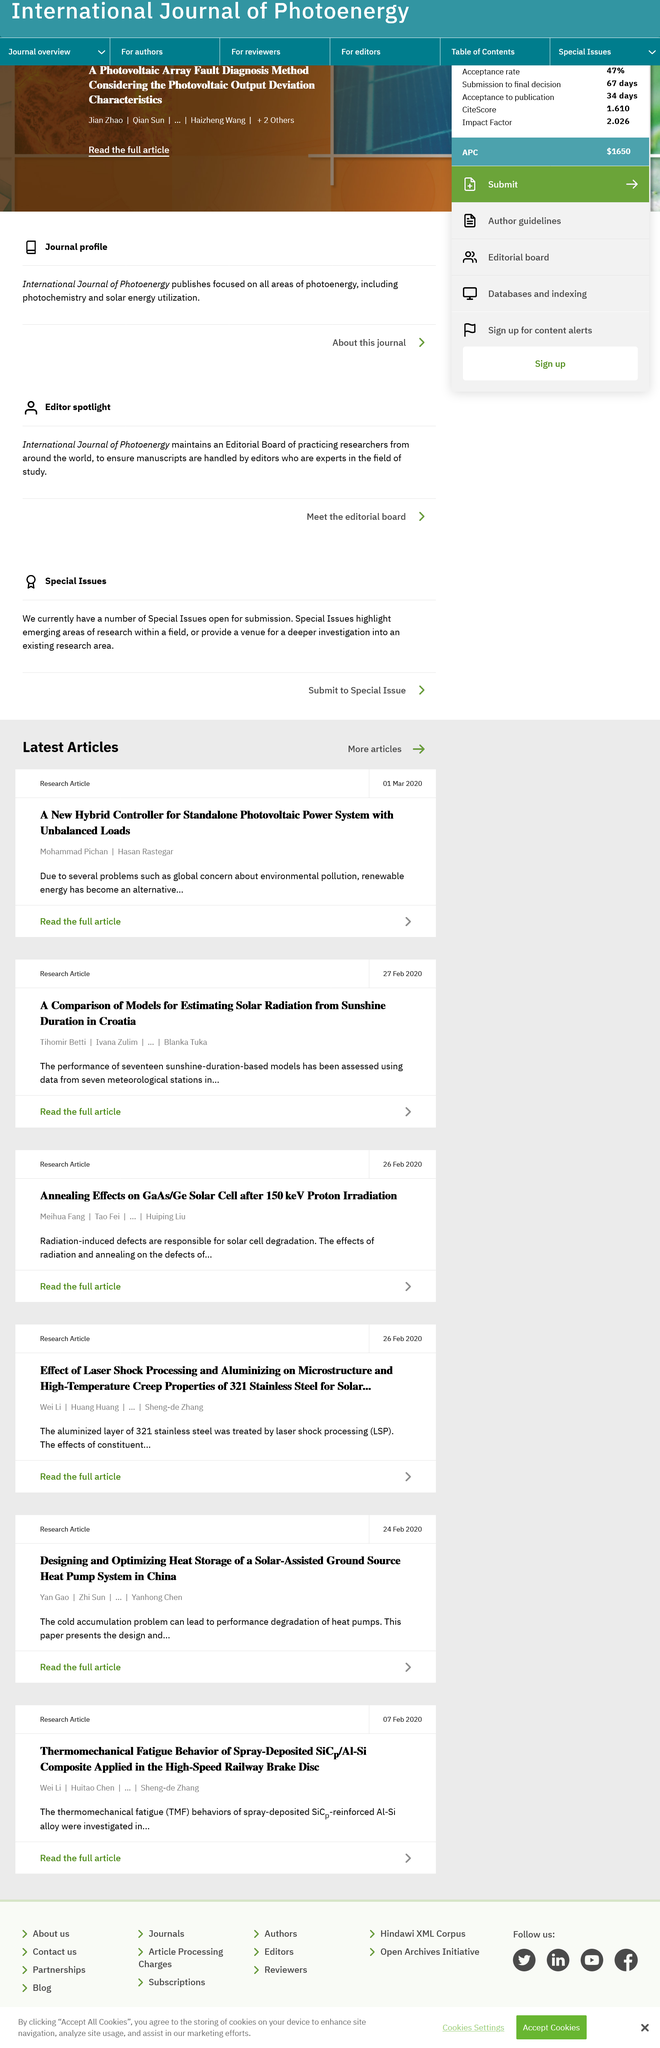Specify some key components in this picture. The authors of the top article are Mohammad Pichan and Hasan Rastegar. The second article assessed a total of seventeen sunshine duration-based models. The second article mentions Croatia. 